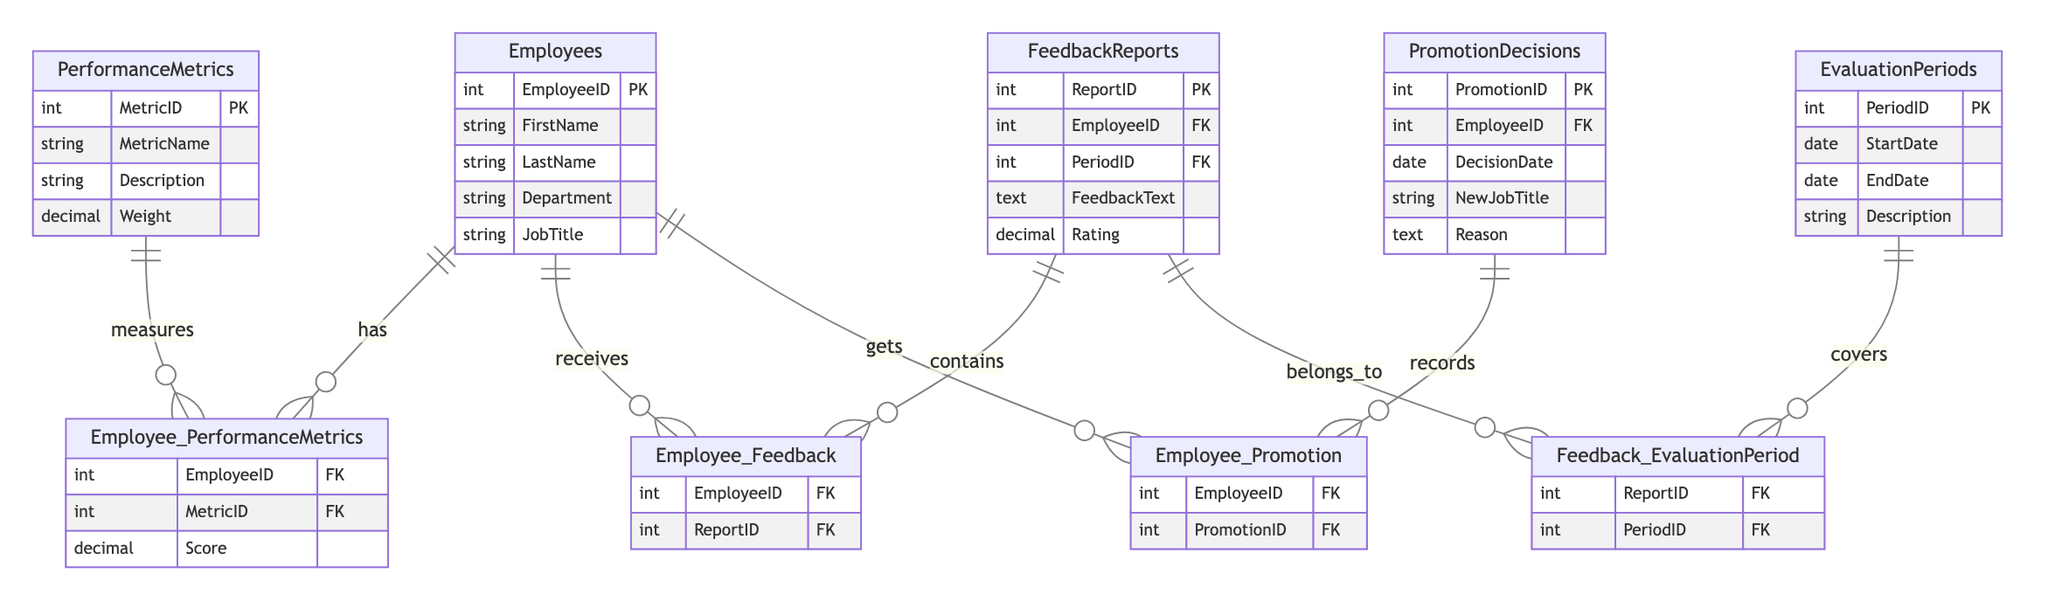What is the primary key of the Employees table? The primary key of the Employees table is indicated by "PK", which designates the EmployeeID as the unique identifier for records in this table.
Answer: EmployeeID How many tables are present in this diagram? By counting the distinct entities or tables listed in the diagram, we have Employees, PerformanceMetrics, EvaluationPeriods, FeedbackReports, and PromotionDecisions, totaling five tables.
Answer: 5 What relationship does the PromotionDecisions table have with the Employees table? The relationship depicted between PromotionDecisions and Employees shows that an employee can receive a promotion decision, suggesting a one-to-many relationship. Employees can have multiple promotion decisions recorded.
Answer: gets What is the weight of the PerformanceMetric? The weight is a property of the PerformanceMetrics table, indicating how significantly a specific metric contributes to the overall performance evaluation, which is represented as a decimal value.
Answer: Decimal Which table contains feedback reports? The FeedbackReports table is designated to hold records of feedback provided to employees during evaluation periods, confirming that it is the table that systematically contains feedback data.
Answer: FeedbackReports Which entity describes the evaluation time frame? EvaluationPeriods provides a structured definition for the range of time over which performance evaluations occur, including details such as start and end dates.
Answer: EvaluationPeriods How many relationships connect Employees to FeedbackReports? The diagram shows that Employees interact with FeedbackReports through the Employee_Feedback relationship, suggesting multiple feedback reports can be associated with one employee. Thus there's a one-to-many relationship.
Answer: 1 What does the PerformanceMetrics table measure? The PerformanceMetrics table quantifies various performance indicators critical to employee evaluations, capturing metrics like MetricID and their specific Weight.
Answer: measures What information does the FeedbackReports table contain? FeedbackReports stores essential feedback data regarding employees, including the feedback text and the associated rating for each report.
Answer: FeedbackText, Rating 